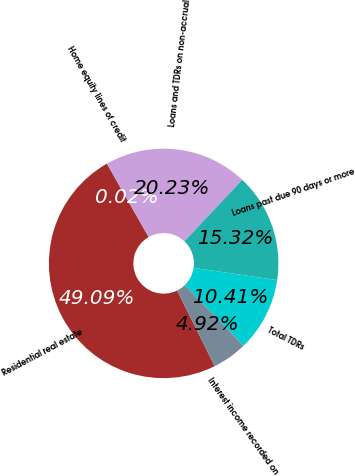Convert chart. <chart><loc_0><loc_0><loc_500><loc_500><pie_chart><fcel>Residential real estate<fcel>Home equity lines of credit<fcel>Loans and TDRs on non-accrual<fcel>Loans past due 90 days or more<fcel>Total TDRs<fcel>Interest income recorded on<nl><fcel>49.09%<fcel>0.02%<fcel>20.23%<fcel>15.32%<fcel>10.41%<fcel>4.92%<nl></chart> 